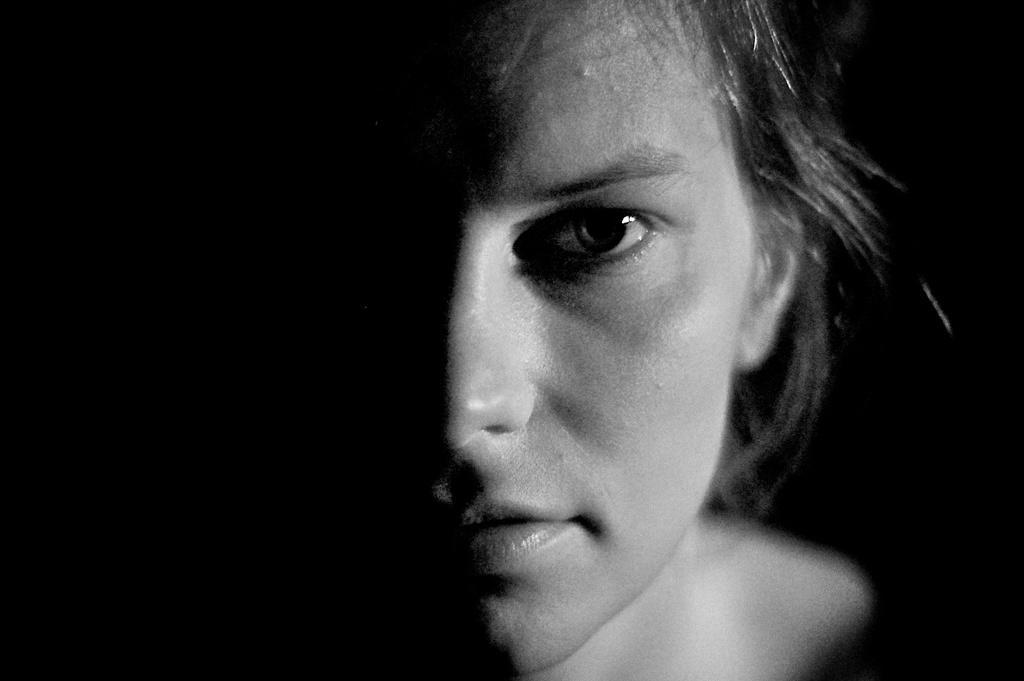How would you summarize this image in a sentence or two? This is a black and white image. I can see the face of a person. There is a black background. 